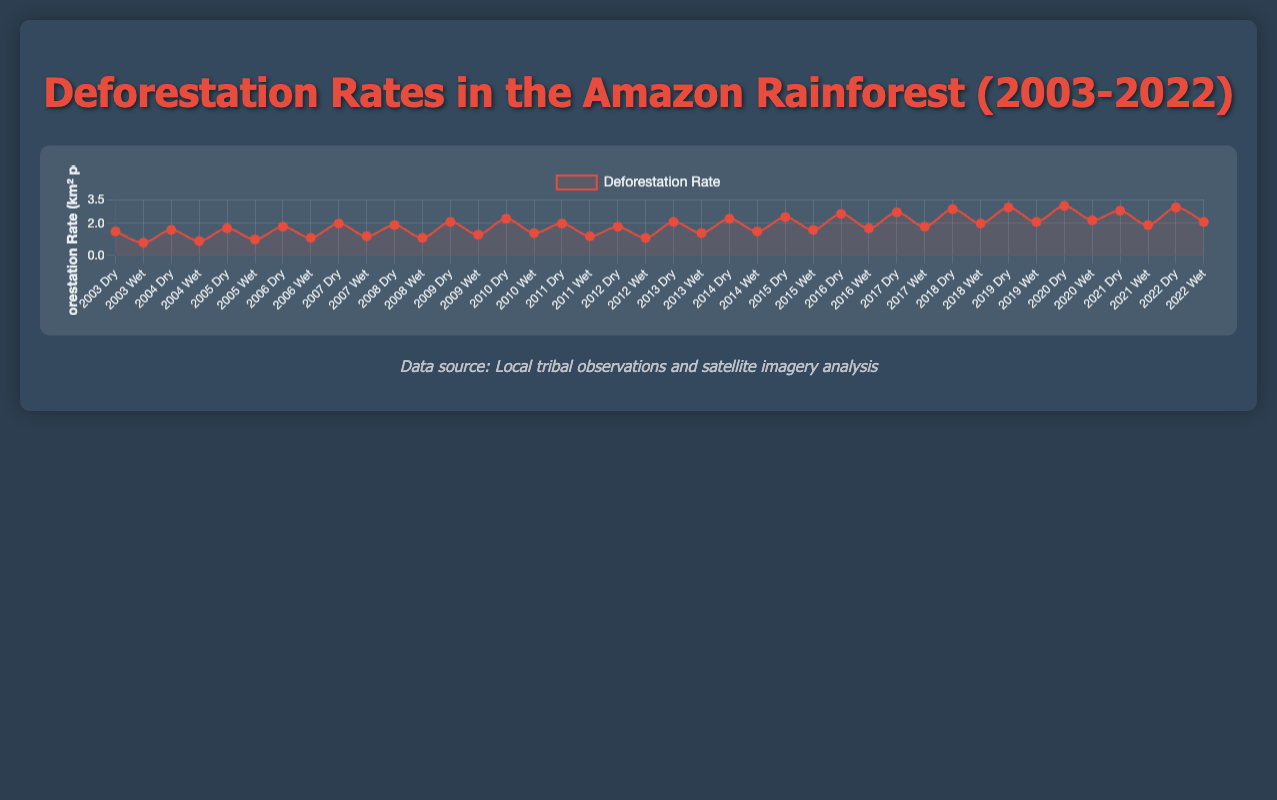What is the average deforestation rate for the dry seasons between 2010 and 2015? First, locate the dry season deforestation rates for each year from 2010 to 2015: 2.3, 2.0, 1.8, 2.1, 2.3, 2.4. Then sum these values: 2.3 + 2.0 + 1.8 + 2.1 + 2.3 + 2.4 = 12.9. Finally, divide the sum by the number of years, which is 6: 12.9 / 6 = 2.15
Answer: 2.15 What is the difference in the average deforestation rate between the dry and wet seasons over the entire period? First, calculate the average deforestation rate for all dry seasons: (1.5 + 1.6 + 1.7 + 1.8 + 2.0 + 1.9 + 2.1 + 2.3 + 2.0 + 1.8 + 2.1 + 2.3 + 2.4 + 2.6 + 2.7 + 2.9 + 3.0 + 3.1 + 2.8 + 3.0) / 20 = 2.24. For the wet seasons: (0.8 + 0.9 + 1.0 + 1.1 + 1.2 + 1.1 + 1.3 + 1.4 + 1.2 + 1.1 + 1.4 + 1.5 + 1.6 + 1.7 + 1.8 + 2.0 + 2.1 + 2.2 + 1.9 + 2.1) / 20 = 1.42. Then find the difference: 2.24 - 1.42 = 0.82
Answer: 0.82 Which season and year had the highest deforestation rate? Observe the plot to identify the data point with the highest deforestation rate. The highest point is in the dry season of 2020, with a rate of 3.1 km² per year.
Answer: Dry season 2020 Which year saw the lowest deforestation rate during the wet season? Look at the datapoints for the wet seasons and find the lowest value. The lowest deforestation rate occurs in 2003 during the wet season, at 0.8 km² per year.
Answer: Wet season 2003 How does the trend in deforestation rates compare between the dry and wet seasons over the years? Refer to the graph and observe the trends. Generally, deforestation rates consistently increase in both seasons, but the dry season shows a more pronounced upward trend compared to the wet seasons.
Answer: Dry seasons show a steeper increase What color is used to represent the deforestation rate data points? The color used to represent the deforestation rate data points is red. This includes both the line and the fill color of the points.
Answer: Red Describe the changes in the line's thickness or visual attributes between the years 2013 and 2014 compared to 2019 and 2020. Between these years, the line maintained its color and thickness (red, with a consistent line width), but the values increased, making it visually appear to move higher on the y-axis.
Answer: No change in thickness; line rises higher Does the chart provide a visual distinction between dry and wet season data points? Yes, the chart uses textual labels on the x-axis, indicating each data point as either "Dry" or "Wet" alongside the year.
Answer: Yes What is the general trend of the deforestation rate according to the chart? The general trend of the deforestation rate, based on the upward trajectory of the lines for both dry and wet seasons, is an increase over time.
Answer: Increasing over time 